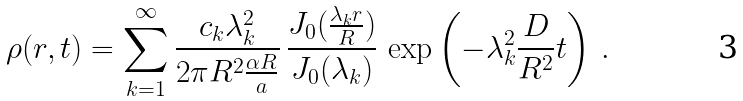Convert formula to latex. <formula><loc_0><loc_0><loc_500><loc_500>\rho ( { r } , t ) = \sum _ { k = 1 } ^ { \infty } \frac { c _ { k } \lambda _ { k } ^ { 2 } } { 2 \pi R ^ { 2 } { \frac { \alpha R } { a } } } \, \frac { J _ { 0 } ( { \frac { \lambda _ { k } r } { R } } ) } { J _ { 0 } ( \lambda _ { k } ) } \, \exp \left ( - \lambda _ { k } ^ { 2 } \frac { D } { R ^ { 2 } } t \right ) \, .</formula> 